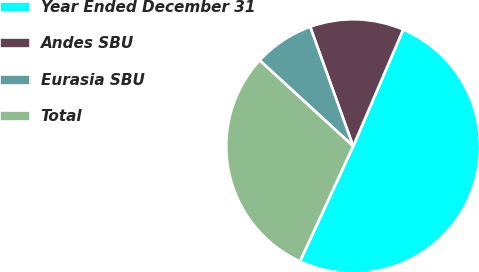<chart> <loc_0><loc_0><loc_500><loc_500><pie_chart><fcel>Year Ended December 31<fcel>Andes SBU<fcel>Eurasia SBU<fcel>Total<nl><fcel>50.44%<fcel>11.95%<fcel>7.68%<fcel>29.93%<nl></chart> 